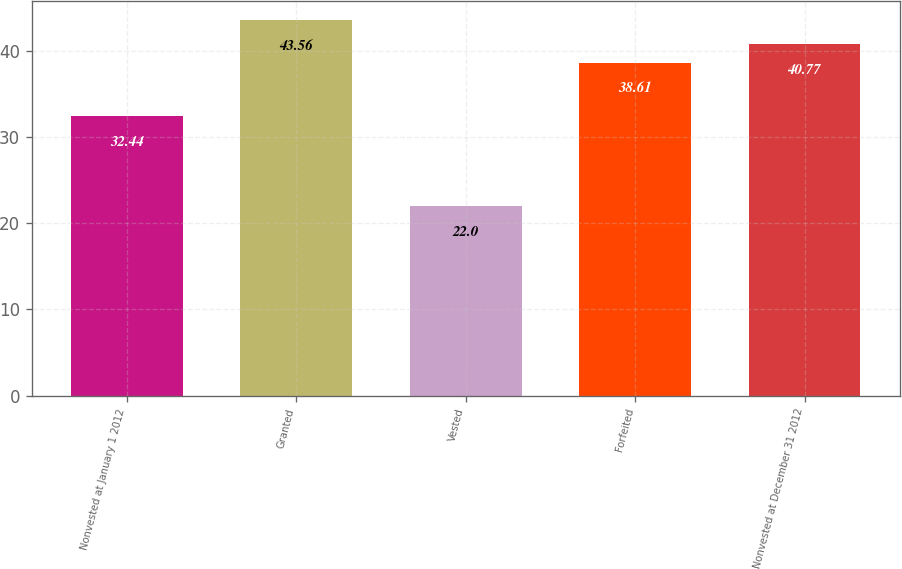Convert chart. <chart><loc_0><loc_0><loc_500><loc_500><bar_chart><fcel>Nonvested at January 1 2012<fcel>Granted<fcel>Vested<fcel>Forfeited<fcel>Nonvested at December 31 2012<nl><fcel>32.44<fcel>43.56<fcel>22<fcel>38.61<fcel>40.77<nl></chart> 